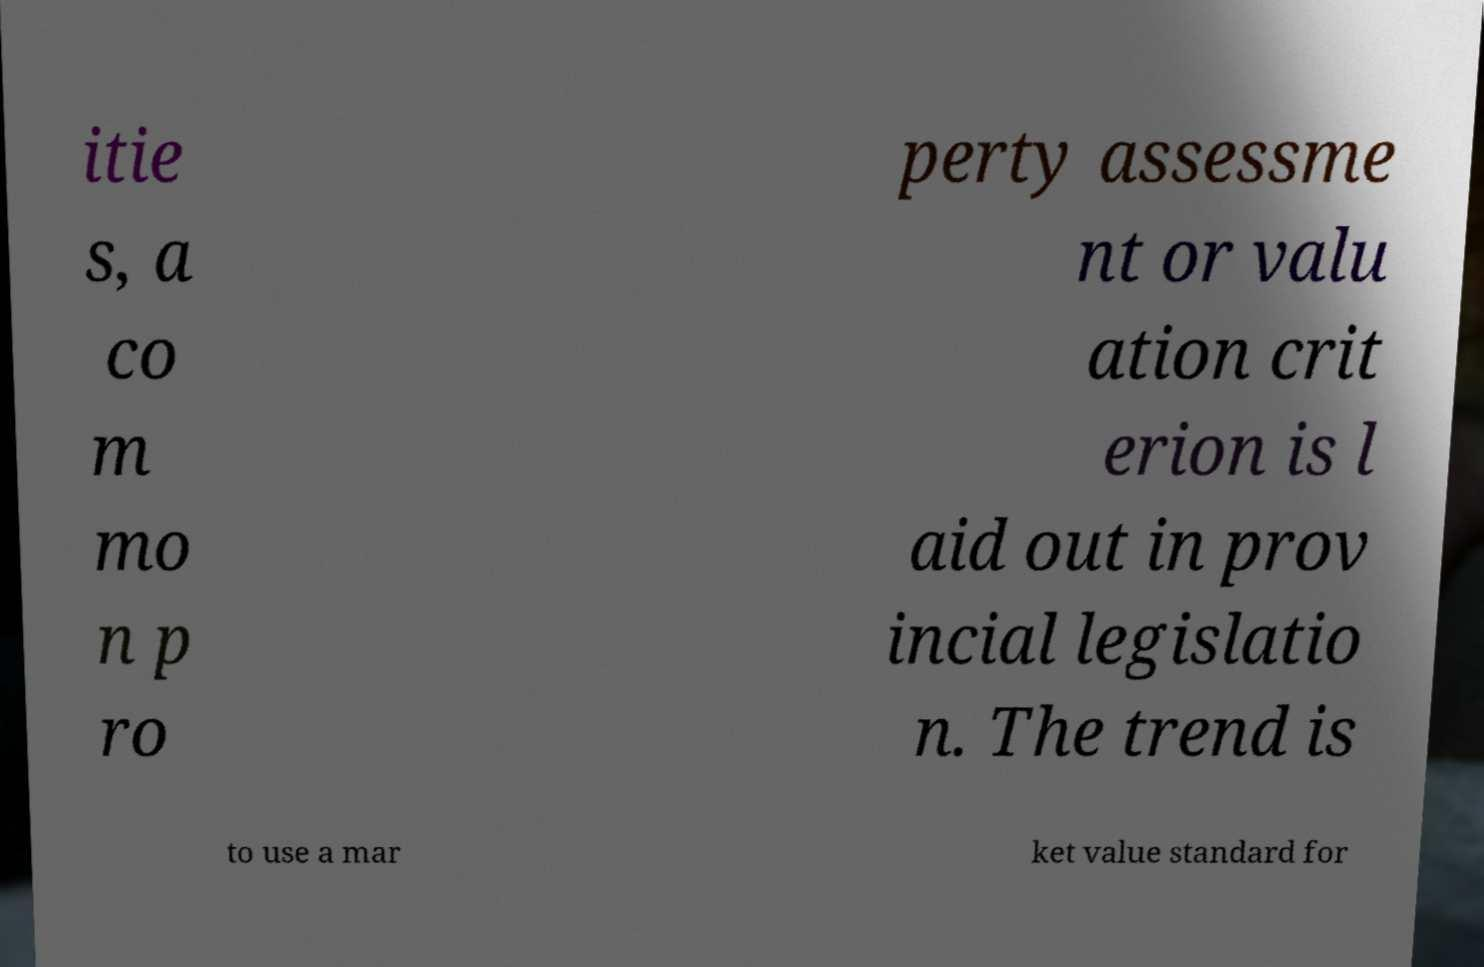Please identify and transcribe the text found in this image. itie s, a co m mo n p ro perty assessme nt or valu ation crit erion is l aid out in prov incial legislatio n. The trend is to use a mar ket value standard for 